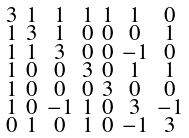<formula> <loc_0><loc_0><loc_500><loc_500>\begin{smallmatrix} 3 & 1 & 1 & 1 & 1 & 1 & 0 \\ 1 & 3 & 1 & 0 & 0 & 0 & 1 \\ 1 & 1 & 3 & 0 & 0 & - 1 & 0 \\ 1 & 0 & 0 & 3 & 0 & 1 & 1 \\ 1 & 0 & 0 & 0 & 3 & 0 & 0 \\ 1 & 0 & - 1 & 1 & 0 & 3 & - 1 \\ 0 & 1 & 0 & 1 & 0 & - 1 & 3 \end{smallmatrix}</formula> 